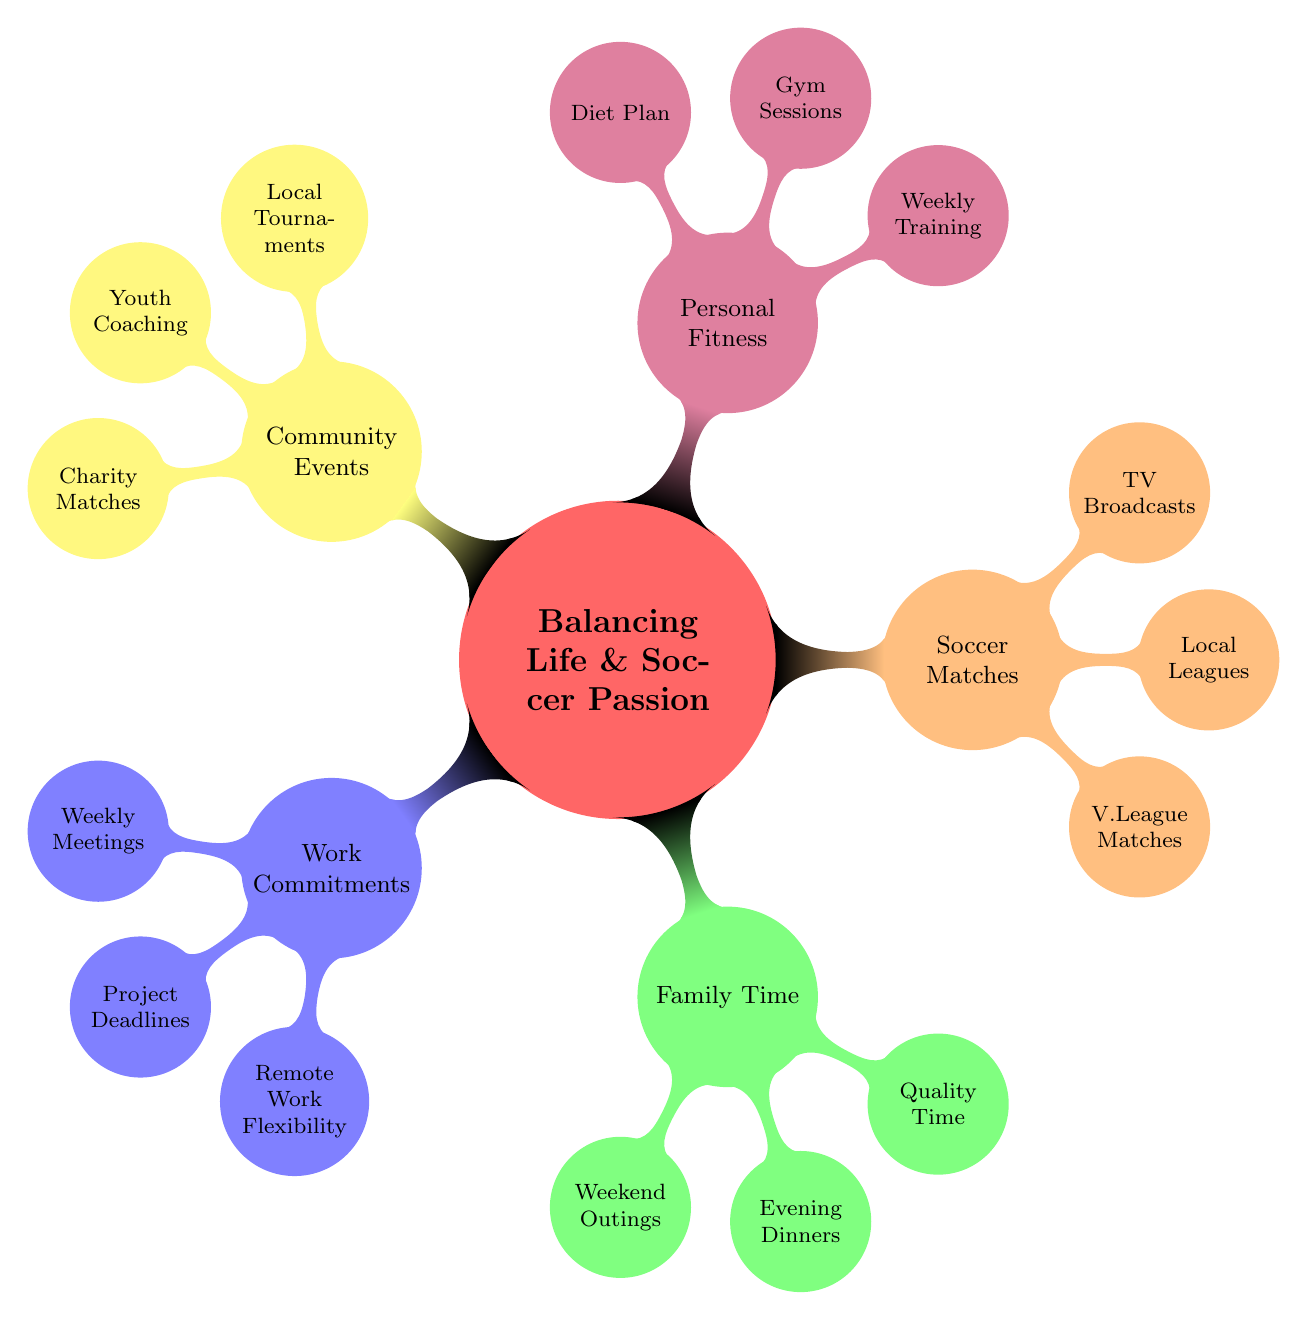What are the weekly meetings listed under Work Commitments? The diagram indicates "Monday stand-up" and "Friday retrospective" as the weekly meetings under the Work Commitments node.
Answer: Monday stand-up, Friday retrospective How many subcategories are under Family Time? The Family Time category has three subcategories: Weekend Outings, Evening Dinners, and Quality Time.
Answer: 3 What personal fitness activity is mentioned for weekly training? The diagram mentions "Jogging at Crissy Field" under Personal Fitness for weekly training.
Answer: Jogging at Crissy Field Which community event is specified as a local tournament? The local tournament specified in the Community Events category is "Tet Soccer Cup."
Answer: Tet Soccer Cup What is the focus of the Youth Coaching activity? The Youth Coaching activity is focused on "Weekend sessions at the Vietnamese Youth Center" as per the diagram.
Answer: Weekend sessions at the Vietnamese Youth Center How does Remote Work Flexibility support Soccer Matches? Remote Work Flexibility provides "Work-from-home days for away game travel," enabling one to attend matches without affecting work commitment.
Answer: Work-from-home days for away game travel What types of matches are mentioned under Soccer Matches Schedule? The types of matches listed include "V.League Matches," "Local Leagues," and "TV Broadcasts."
Answer: V.League Matches, Local Leagues, TV Broadcasts Which category includes evening family activities? Evening family activities are included in the Family Time category, specifically the "Evening Dinners" subcategory.
Answer: Family Time What is the concept of balancing life according to the mind map? The concept involves harmonizing "Work Commitments," "Family Time," "Soccer Matches Schedule," "Personal Fitness," and "Community Soccer Events" in one’s life.
Answer: Balancing Life & Soccer Passion 